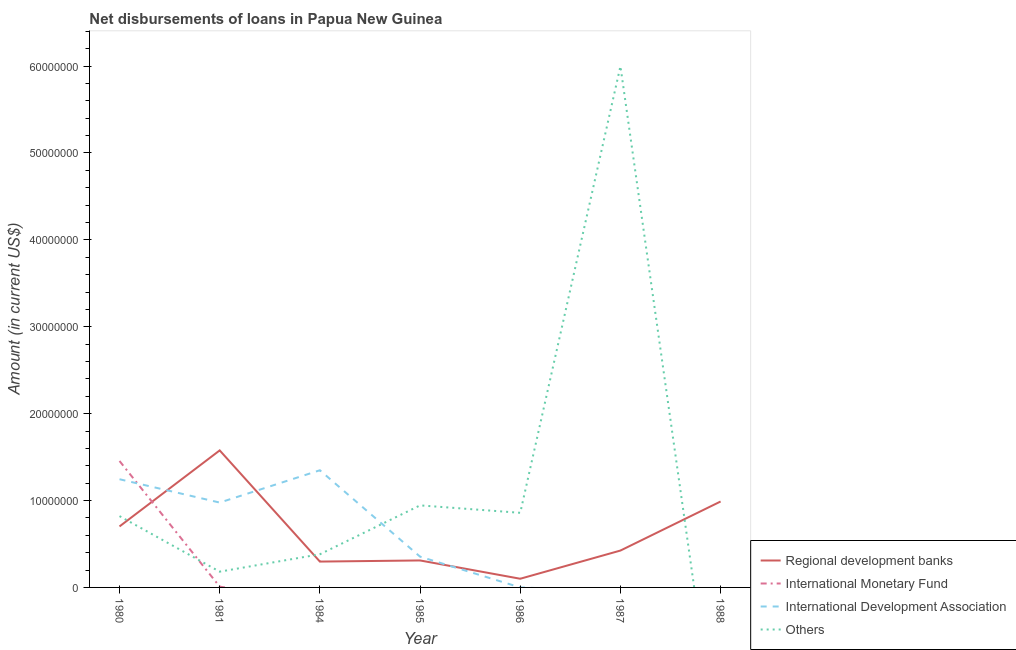Does the line corresponding to amount of loan disimbursed by regional development banks intersect with the line corresponding to amount of loan disimbursed by international development association?
Offer a terse response. Yes. Is the number of lines equal to the number of legend labels?
Offer a terse response. No. What is the amount of loan disimbursed by other organisations in 1980?
Ensure brevity in your answer.  8.21e+06. Across all years, what is the maximum amount of loan disimbursed by international development association?
Provide a succinct answer. 1.35e+07. In which year was the amount of loan disimbursed by international development association maximum?
Your answer should be very brief. 1984. What is the total amount of loan disimbursed by regional development banks in the graph?
Make the answer very short. 4.40e+07. What is the difference between the amount of loan disimbursed by other organisations in 1980 and that in 1986?
Give a very brief answer. -3.80e+05. What is the difference between the amount of loan disimbursed by international development association in 1985 and the amount of loan disimbursed by other organisations in 1980?
Your response must be concise. -4.67e+06. What is the average amount of loan disimbursed by other organisations per year?
Keep it short and to the point. 1.31e+07. In the year 1981, what is the difference between the amount of loan disimbursed by international monetary fund and amount of loan disimbursed by international development association?
Offer a terse response. -9.68e+06. In how many years, is the amount of loan disimbursed by regional development banks greater than 26000000 US$?
Provide a short and direct response. 0. What is the ratio of the amount of loan disimbursed by regional development banks in 1980 to that in 1987?
Ensure brevity in your answer.  1.65. Is the amount of loan disimbursed by regional development banks in 1981 less than that in 1984?
Your answer should be compact. No. What is the difference between the highest and the second highest amount of loan disimbursed by international development association?
Offer a terse response. 1.03e+06. What is the difference between the highest and the lowest amount of loan disimbursed by other organisations?
Offer a very short reply. 6.00e+07. In how many years, is the amount of loan disimbursed by other organisations greater than the average amount of loan disimbursed by other organisations taken over all years?
Offer a terse response. 1. Is it the case that in every year, the sum of the amount of loan disimbursed by regional development banks and amount of loan disimbursed by other organisations is greater than the sum of amount of loan disimbursed by international development association and amount of loan disimbursed by international monetary fund?
Your answer should be compact. No. Is it the case that in every year, the sum of the amount of loan disimbursed by regional development banks and amount of loan disimbursed by international monetary fund is greater than the amount of loan disimbursed by international development association?
Your answer should be compact. No. Does the amount of loan disimbursed by regional development banks monotonically increase over the years?
Provide a short and direct response. No. Is the amount of loan disimbursed by regional development banks strictly greater than the amount of loan disimbursed by international development association over the years?
Your response must be concise. No. How many lines are there?
Offer a terse response. 4. Does the graph contain any zero values?
Ensure brevity in your answer.  Yes. Where does the legend appear in the graph?
Your answer should be very brief. Bottom right. How many legend labels are there?
Give a very brief answer. 4. How are the legend labels stacked?
Your response must be concise. Vertical. What is the title of the graph?
Provide a succinct answer. Net disbursements of loans in Papua New Guinea. Does "Periodicity assessment" appear as one of the legend labels in the graph?
Keep it short and to the point. No. What is the label or title of the X-axis?
Provide a short and direct response. Year. What is the label or title of the Y-axis?
Your response must be concise. Amount (in current US$). What is the Amount (in current US$) of Regional development banks in 1980?
Keep it short and to the point. 7.02e+06. What is the Amount (in current US$) in International Monetary Fund in 1980?
Your answer should be very brief. 1.46e+07. What is the Amount (in current US$) in International Development Association in 1980?
Provide a short and direct response. 1.25e+07. What is the Amount (in current US$) of Others in 1980?
Ensure brevity in your answer.  8.21e+06. What is the Amount (in current US$) in Regional development banks in 1981?
Make the answer very short. 1.58e+07. What is the Amount (in current US$) in International Development Association in 1981?
Your answer should be compact. 9.77e+06. What is the Amount (in current US$) of Others in 1981?
Provide a short and direct response. 1.82e+06. What is the Amount (in current US$) in Regional development banks in 1984?
Your answer should be very brief. 2.98e+06. What is the Amount (in current US$) in International Development Association in 1984?
Make the answer very short. 1.35e+07. What is the Amount (in current US$) of Others in 1984?
Provide a succinct answer. 3.82e+06. What is the Amount (in current US$) of Regional development banks in 1985?
Keep it short and to the point. 3.10e+06. What is the Amount (in current US$) in International Monetary Fund in 1985?
Offer a terse response. 0. What is the Amount (in current US$) of International Development Association in 1985?
Ensure brevity in your answer.  3.54e+06. What is the Amount (in current US$) of Others in 1985?
Ensure brevity in your answer.  9.44e+06. What is the Amount (in current US$) in Regional development banks in 1986?
Your answer should be very brief. 9.99e+05. What is the Amount (in current US$) in International Monetary Fund in 1986?
Make the answer very short. 0. What is the Amount (in current US$) in International Development Association in 1986?
Provide a succinct answer. 0. What is the Amount (in current US$) of Others in 1986?
Your response must be concise. 8.59e+06. What is the Amount (in current US$) in Regional development banks in 1987?
Offer a very short reply. 4.24e+06. What is the Amount (in current US$) in International Development Association in 1987?
Make the answer very short. 0. What is the Amount (in current US$) of Others in 1987?
Offer a terse response. 6.00e+07. What is the Amount (in current US$) of Regional development banks in 1988?
Provide a short and direct response. 9.89e+06. What is the Amount (in current US$) in International Monetary Fund in 1988?
Provide a succinct answer. 0. What is the Amount (in current US$) of Others in 1988?
Your response must be concise. 0. Across all years, what is the maximum Amount (in current US$) of Regional development banks?
Your answer should be very brief. 1.58e+07. Across all years, what is the maximum Amount (in current US$) in International Monetary Fund?
Your answer should be compact. 1.46e+07. Across all years, what is the maximum Amount (in current US$) of International Development Association?
Give a very brief answer. 1.35e+07. Across all years, what is the maximum Amount (in current US$) in Others?
Make the answer very short. 6.00e+07. Across all years, what is the minimum Amount (in current US$) in Regional development banks?
Make the answer very short. 9.99e+05. Across all years, what is the minimum Amount (in current US$) in Others?
Your response must be concise. 0. What is the total Amount (in current US$) in Regional development banks in the graph?
Keep it short and to the point. 4.40e+07. What is the total Amount (in current US$) in International Monetary Fund in the graph?
Your answer should be very brief. 1.46e+07. What is the total Amount (in current US$) of International Development Association in the graph?
Keep it short and to the point. 3.92e+07. What is the total Amount (in current US$) in Others in the graph?
Your answer should be very brief. 9.19e+07. What is the difference between the Amount (in current US$) in Regional development banks in 1980 and that in 1981?
Give a very brief answer. -8.75e+06. What is the difference between the Amount (in current US$) in International Monetary Fund in 1980 and that in 1981?
Make the answer very short. 1.45e+07. What is the difference between the Amount (in current US$) of International Development Association in 1980 and that in 1981?
Provide a succinct answer. 2.69e+06. What is the difference between the Amount (in current US$) in Others in 1980 and that in 1981?
Make the answer very short. 6.39e+06. What is the difference between the Amount (in current US$) in Regional development banks in 1980 and that in 1984?
Your response must be concise. 4.04e+06. What is the difference between the Amount (in current US$) of International Development Association in 1980 and that in 1984?
Offer a very short reply. -1.03e+06. What is the difference between the Amount (in current US$) of Others in 1980 and that in 1984?
Provide a short and direct response. 4.39e+06. What is the difference between the Amount (in current US$) in Regional development banks in 1980 and that in 1985?
Your answer should be very brief. 3.91e+06. What is the difference between the Amount (in current US$) in International Development Association in 1980 and that in 1985?
Provide a succinct answer. 8.91e+06. What is the difference between the Amount (in current US$) in Others in 1980 and that in 1985?
Your answer should be compact. -1.24e+06. What is the difference between the Amount (in current US$) of Regional development banks in 1980 and that in 1986?
Provide a short and direct response. 6.02e+06. What is the difference between the Amount (in current US$) of Others in 1980 and that in 1986?
Keep it short and to the point. -3.80e+05. What is the difference between the Amount (in current US$) in Regional development banks in 1980 and that in 1987?
Offer a terse response. 2.78e+06. What is the difference between the Amount (in current US$) in Others in 1980 and that in 1987?
Make the answer very short. -5.18e+07. What is the difference between the Amount (in current US$) in Regional development banks in 1980 and that in 1988?
Your answer should be compact. -2.87e+06. What is the difference between the Amount (in current US$) of Regional development banks in 1981 and that in 1984?
Make the answer very short. 1.28e+07. What is the difference between the Amount (in current US$) in International Development Association in 1981 and that in 1984?
Keep it short and to the point. -3.72e+06. What is the difference between the Amount (in current US$) of Regional development banks in 1981 and that in 1985?
Your response must be concise. 1.27e+07. What is the difference between the Amount (in current US$) of International Development Association in 1981 and that in 1985?
Keep it short and to the point. 6.23e+06. What is the difference between the Amount (in current US$) of Others in 1981 and that in 1985?
Make the answer very short. -7.63e+06. What is the difference between the Amount (in current US$) of Regional development banks in 1981 and that in 1986?
Provide a succinct answer. 1.48e+07. What is the difference between the Amount (in current US$) of Others in 1981 and that in 1986?
Offer a very short reply. -6.77e+06. What is the difference between the Amount (in current US$) of Regional development banks in 1981 and that in 1987?
Make the answer very short. 1.15e+07. What is the difference between the Amount (in current US$) of Others in 1981 and that in 1987?
Provide a short and direct response. -5.82e+07. What is the difference between the Amount (in current US$) in Regional development banks in 1981 and that in 1988?
Provide a short and direct response. 5.88e+06. What is the difference between the Amount (in current US$) of Regional development banks in 1984 and that in 1985?
Ensure brevity in your answer.  -1.30e+05. What is the difference between the Amount (in current US$) of International Development Association in 1984 and that in 1985?
Offer a terse response. 9.94e+06. What is the difference between the Amount (in current US$) in Others in 1984 and that in 1985?
Provide a short and direct response. -5.63e+06. What is the difference between the Amount (in current US$) of Regional development banks in 1984 and that in 1986?
Offer a very short reply. 1.98e+06. What is the difference between the Amount (in current US$) in Others in 1984 and that in 1986?
Your response must be concise. -4.77e+06. What is the difference between the Amount (in current US$) of Regional development banks in 1984 and that in 1987?
Keep it short and to the point. -1.27e+06. What is the difference between the Amount (in current US$) in Others in 1984 and that in 1987?
Offer a very short reply. -5.62e+07. What is the difference between the Amount (in current US$) of Regional development banks in 1984 and that in 1988?
Your answer should be compact. -6.92e+06. What is the difference between the Amount (in current US$) of Regional development banks in 1985 and that in 1986?
Give a very brief answer. 2.11e+06. What is the difference between the Amount (in current US$) of Others in 1985 and that in 1986?
Your answer should be very brief. 8.56e+05. What is the difference between the Amount (in current US$) of Regional development banks in 1985 and that in 1987?
Your answer should be compact. -1.14e+06. What is the difference between the Amount (in current US$) in Others in 1985 and that in 1987?
Offer a terse response. -5.05e+07. What is the difference between the Amount (in current US$) of Regional development banks in 1985 and that in 1988?
Your response must be concise. -6.79e+06. What is the difference between the Amount (in current US$) in Regional development banks in 1986 and that in 1987?
Give a very brief answer. -3.24e+06. What is the difference between the Amount (in current US$) of Others in 1986 and that in 1987?
Your answer should be very brief. -5.14e+07. What is the difference between the Amount (in current US$) of Regional development banks in 1986 and that in 1988?
Provide a short and direct response. -8.89e+06. What is the difference between the Amount (in current US$) in Regional development banks in 1987 and that in 1988?
Offer a very short reply. -5.65e+06. What is the difference between the Amount (in current US$) in Regional development banks in 1980 and the Amount (in current US$) in International Monetary Fund in 1981?
Your answer should be very brief. 6.93e+06. What is the difference between the Amount (in current US$) of Regional development banks in 1980 and the Amount (in current US$) of International Development Association in 1981?
Make the answer very short. -2.75e+06. What is the difference between the Amount (in current US$) in Regional development banks in 1980 and the Amount (in current US$) in Others in 1981?
Offer a very short reply. 5.20e+06. What is the difference between the Amount (in current US$) in International Monetary Fund in 1980 and the Amount (in current US$) in International Development Association in 1981?
Your answer should be compact. 4.79e+06. What is the difference between the Amount (in current US$) of International Monetary Fund in 1980 and the Amount (in current US$) of Others in 1981?
Offer a terse response. 1.27e+07. What is the difference between the Amount (in current US$) of International Development Association in 1980 and the Amount (in current US$) of Others in 1981?
Your answer should be very brief. 1.06e+07. What is the difference between the Amount (in current US$) of Regional development banks in 1980 and the Amount (in current US$) of International Development Association in 1984?
Make the answer very short. -6.46e+06. What is the difference between the Amount (in current US$) of Regional development banks in 1980 and the Amount (in current US$) of Others in 1984?
Provide a short and direct response. 3.20e+06. What is the difference between the Amount (in current US$) of International Monetary Fund in 1980 and the Amount (in current US$) of International Development Association in 1984?
Your answer should be compact. 1.07e+06. What is the difference between the Amount (in current US$) in International Monetary Fund in 1980 and the Amount (in current US$) in Others in 1984?
Make the answer very short. 1.07e+07. What is the difference between the Amount (in current US$) in International Development Association in 1980 and the Amount (in current US$) in Others in 1984?
Your response must be concise. 8.64e+06. What is the difference between the Amount (in current US$) of Regional development banks in 1980 and the Amount (in current US$) of International Development Association in 1985?
Give a very brief answer. 3.48e+06. What is the difference between the Amount (in current US$) of Regional development banks in 1980 and the Amount (in current US$) of Others in 1985?
Give a very brief answer. -2.42e+06. What is the difference between the Amount (in current US$) of International Monetary Fund in 1980 and the Amount (in current US$) of International Development Association in 1985?
Provide a short and direct response. 1.10e+07. What is the difference between the Amount (in current US$) of International Monetary Fund in 1980 and the Amount (in current US$) of Others in 1985?
Keep it short and to the point. 5.11e+06. What is the difference between the Amount (in current US$) in International Development Association in 1980 and the Amount (in current US$) in Others in 1985?
Offer a very short reply. 3.01e+06. What is the difference between the Amount (in current US$) in Regional development banks in 1980 and the Amount (in current US$) in Others in 1986?
Your answer should be compact. -1.57e+06. What is the difference between the Amount (in current US$) of International Monetary Fund in 1980 and the Amount (in current US$) of Others in 1986?
Your answer should be very brief. 5.96e+06. What is the difference between the Amount (in current US$) of International Development Association in 1980 and the Amount (in current US$) of Others in 1986?
Provide a succinct answer. 3.86e+06. What is the difference between the Amount (in current US$) in Regional development banks in 1980 and the Amount (in current US$) in Others in 1987?
Make the answer very short. -5.30e+07. What is the difference between the Amount (in current US$) of International Monetary Fund in 1980 and the Amount (in current US$) of Others in 1987?
Give a very brief answer. -4.54e+07. What is the difference between the Amount (in current US$) of International Development Association in 1980 and the Amount (in current US$) of Others in 1987?
Offer a very short reply. -4.75e+07. What is the difference between the Amount (in current US$) of Regional development banks in 1981 and the Amount (in current US$) of International Development Association in 1984?
Your response must be concise. 2.29e+06. What is the difference between the Amount (in current US$) of Regional development banks in 1981 and the Amount (in current US$) of Others in 1984?
Keep it short and to the point. 1.20e+07. What is the difference between the Amount (in current US$) in International Monetary Fund in 1981 and the Amount (in current US$) in International Development Association in 1984?
Your answer should be very brief. -1.34e+07. What is the difference between the Amount (in current US$) of International Monetary Fund in 1981 and the Amount (in current US$) of Others in 1984?
Your response must be concise. -3.72e+06. What is the difference between the Amount (in current US$) in International Development Association in 1981 and the Amount (in current US$) in Others in 1984?
Your response must be concise. 5.95e+06. What is the difference between the Amount (in current US$) of Regional development banks in 1981 and the Amount (in current US$) of International Development Association in 1985?
Provide a short and direct response. 1.22e+07. What is the difference between the Amount (in current US$) of Regional development banks in 1981 and the Amount (in current US$) of Others in 1985?
Your answer should be very brief. 6.33e+06. What is the difference between the Amount (in current US$) in International Monetary Fund in 1981 and the Amount (in current US$) in International Development Association in 1985?
Offer a very short reply. -3.45e+06. What is the difference between the Amount (in current US$) of International Monetary Fund in 1981 and the Amount (in current US$) of Others in 1985?
Your response must be concise. -9.35e+06. What is the difference between the Amount (in current US$) in International Development Association in 1981 and the Amount (in current US$) in Others in 1985?
Offer a very short reply. 3.23e+05. What is the difference between the Amount (in current US$) of Regional development banks in 1981 and the Amount (in current US$) of Others in 1986?
Ensure brevity in your answer.  7.18e+06. What is the difference between the Amount (in current US$) in International Monetary Fund in 1981 and the Amount (in current US$) in Others in 1986?
Make the answer very short. -8.50e+06. What is the difference between the Amount (in current US$) in International Development Association in 1981 and the Amount (in current US$) in Others in 1986?
Give a very brief answer. 1.18e+06. What is the difference between the Amount (in current US$) in Regional development banks in 1981 and the Amount (in current US$) in Others in 1987?
Provide a succinct answer. -4.42e+07. What is the difference between the Amount (in current US$) in International Monetary Fund in 1981 and the Amount (in current US$) in Others in 1987?
Your answer should be compact. -5.99e+07. What is the difference between the Amount (in current US$) in International Development Association in 1981 and the Amount (in current US$) in Others in 1987?
Your response must be concise. -5.02e+07. What is the difference between the Amount (in current US$) in Regional development banks in 1984 and the Amount (in current US$) in International Development Association in 1985?
Ensure brevity in your answer.  -5.65e+05. What is the difference between the Amount (in current US$) of Regional development banks in 1984 and the Amount (in current US$) of Others in 1985?
Provide a succinct answer. -6.47e+06. What is the difference between the Amount (in current US$) of International Development Association in 1984 and the Amount (in current US$) of Others in 1985?
Ensure brevity in your answer.  4.04e+06. What is the difference between the Amount (in current US$) in Regional development banks in 1984 and the Amount (in current US$) in Others in 1986?
Provide a succinct answer. -5.61e+06. What is the difference between the Amount (in current US$) of International Development Association in 1984 and the Amount (in current US$) of Others in 1986?
Give a very brief answer. 4.90e+06. What is the difference between the Amount (in current US$) of Regional development banks in 1984 and the Amount (in current US$) of Others in 1987?
Make the answer very short. -5.70e+07. What is the difference between the Amount (in current US$) in International Development Association in 1984 and the Amount (in current US$) in Others in 1987?
Keep it short and to the point. -4.65e+07. What is the difference between the Amount (in current US$) of Regional development banks in 1985 and the Amount (in current US$) of Others in 1986?
Your answer should be very brief. -5.48e+06. What is the difference between the Amount (in current US$) of International Development Association in 1985 and the Amount (in current US$) of Others in 1986?
Your response must be concise. -5.05e+06. What is the difference between the Amount (in current US$) in Regional development banks in 1985 and the Amount (in current US$) in Others in 1987?
Provide a succinct answer. -5.69e+07. What is the difference between the Amount (in current US$) in International Development Association in 1985 and the Amount (in current US$) in Others in 1987?
Keep it short and to the point. -5.64e+07. What is the difference between the Amount (in current US$) in Regional development banks in 1986 and the Amount (in current US$) in Others in 1987?
Ensure brevity in your answer.  -5.90e+07. What is the average Amount (in current US$) in Regional development banks per year?
Provide a succinct answer. 6.29e+06. What is the average Amount (in current US$) of International Monetary Fund per year?
Ensure brevity in your answer.  2.09e+06. What is the average Amount (in current US$) of International Development Association per year?
Provide a short and direct response. 5.61e+06. What is the average Amount (in current US$) in Others per year?
Offer a terse response. 1.31e+07. In the year 1980, what is the difference between the Amount (in current US$) in Regional development banks and Amount (in current US$) in International Monetary Fund?
Offer a terse response. -7.53e+06. In the year 1980, what is the difference between the Amount (in current US$) of Regional development banks and Amount (in current US$) of International Development Association?
Provide a short and direct response. -5.43e+06. In the year 1980, what is the difference between the Amount (in current US$) of Regional development banks and Amount (in current US$) of Others?
Offer a very short reply. -1.19e+06. In the year 1980, what is the difference between the Amount (in current US$) in International Monetary Fund and Amount (in current US$) in International Development Association?
Provide a succinct answer. 2.10e+06. In the year 1980, what is the difference between the Amount (in current US$) in International Monetary Fund and Amount (in current US$) in Others?
Provide a short and direct response. 6.34e+06. In the year 1980, what is the difference between the Amount (in current US$) of International Development Association and Amount (in current US$) of Others?
Your answer should be compact. 4.24e+06. In the year 1981, what is the difference between the Amount (in current US$) in Regional development banks and Amount (in current US$) in International Monetary Fund?
Keep it short and to the point. 1.57e+07. In the year 1981, what is the difference between the Amount (in current US$) of Regional development banks and Amount (in current US$) of International Development Association?
Your answer should be very brief. 6.00e+06. In the year 1981, what is the difference between the Amount (in current US$) of Regional development banks and Amount (in current US$) of Others?
Offer a terse response. 1.40e+07. In the year 1981, what is the difference between the Amount (in current US$) in International Monetary Fund and Amount (in current US$) in International Development Association?
Provide a succinct answer. -9.68e+06. In the year 1981, what is the difference between the Amount (in current US$) of International Monetary Fund and Amount (in current US$) of Others?
Give a very brief answer. -1.72e+06. In the year 1981, what is the difference between the Amount (in current US$) in International Development Association and Amount (in current US$) in Others?
Ensure brevity in your answer.  7.95e+06. In the year 1984, what is the difference between the Amount (in current US$) in Regional development banks and Amount (in current US$) in International Development Association?
Your answer should be compact. -1.05e+07. In the year 1984, what is the difference between the Amount (in current US$) in Regional development banks and Amount (in current US$) in Others?
Provide a short and direct response. -8.40e+05. In the year 1984, what is the difference between the Amount (in current US$) in International Development Association and Amount (in current US$) in Others?
Provide a short and direct response. 9.67e+06. In the year 1985, what is the difference between the Amount (in current US$) in Regional development banks and Amount (in current US$) in International Development Association?
Keep it short and to the point. -4.35e+05. In the year 1985, what is the difference between the Amount (in current US$) in Regional development banks and Amount (in current US$) in Others?
Offer a terse response. -6.34e+06. In the year 1985, what is the difference between the Amount (in current US$) in International Development Association and Amount (in current US$) in Others?
Provide a succinct answer. -5.90e+06. In the year 1986, what is the difference between the Amount (in current US$) of Regional development banks and Amount (in current US$) of Others?
Keep it short and to the point. -7.59e+06. In the year 1987, what is the difference between the Amount (in current US$) in Regional development banks and Amount (in current US$) in Others?
Provide a short and direct response. -5.57e+07. What is the ratio of the Amount (in current US$) in Regional development banks in 1980 to that in 1981?
Offer a terse response. 0.45. What is the ratio of the Amount (in current US$) of International Monetary Fund in 1980 to that in 1981?
Give a very brief answer. 161.69. What is the ratio of the Amount (in current US$) in International Development Association in 1980 to that in 1981?
Give a very brief answer. 1.27. What is the ratio of the Amount (in current US$) in Others in 1980 to that in 1981?
Your answer should be compact. 4.52. What is the ratio of the Amount (in current US$) in Regional development banks in 1980 to that in 1984?
Provide a short and direct response. 2.36. What is the ratio of the Amount (in current US$) of International Development Association in 1980 to that in 1984?
Offer a terse response. 0.92. What is the ratio of the Amount (in current US$) in Others in 1980 to that in 1984?
Your answer should be very brief. 2.15. What is the ratio of the Amount (in current US$) in Regional development banks in 1980 to that in 1985?
Keep it short and to the point. 2.26. What is the ratio of the Amount (in current US$) in International Development Association in 1980 to that in 1985?
Provide a short and direct response. 3.52. What is the ratio of the Amount (in current US$) in Others in 1980 to that in 1985?
Give a very brief answer. 0.87. What is the ratio of the Amount (in current US$) of Regional development banks in 1980 to that in 1986?
Provide a short and direct response. 7.03. What is the ratio of the Amount (in current US$) in Others in 1980 to that in 1986?
Keep it short and to the point. 0.96. What is the ratio of the Amount (in current US$) in Regional development banks in 1980 to that in 1987?
Provide a succinct answer. 1.65. What is the ratio of the Amount (in current US$) of Others in 1980 to that in 1987?
Make the answer very short. 0.14. What is the ratio of the Amount (in current US$) in Regional development banks in 1980 to that in 1988?
Provide a short and direct response. 0.71. What is the ratio of the Amount (in current US$) of Regional development banks in 1981 to that in 1984?
Keep it short and to the point. 5.3. What is the ratio of the Amount (in current US$) in International Development Association in 1981 to that in 1984?
Your answer should be very brief. 0.72. What is the ratio of the Amount (in current US$) of Others in 1981 to that in 1984?
Offer a terse response. 0.48. What is the ratio of the Amount (in current US$) in Regional development banks in 1981 to that in 1985?
Provide a succinct answer. 5.08. What is the ratio of the Amount (in current US$) in International Development Association in 1981 to that in 1985?
Make the answer very short. 2.76. What is the ratio of the Amount (in current US$) in Others in 1981 to that in 1985?
Offer a terse response. 0.19. What is the ratio of the Amount (in current US$) of Regional development banks in 1981 to that in 1986?
Offer a very short reply. 15.79. What is the ratio of the Amount (in current US$) of Others in 1981 to that in 1986?
Your answer should be compact. 0.21. What is the ratio of the Amount (in current US$) in Regional development banks in 1981 to that in 1987?
Your answer should be compact. 3.72. What is the ratio of the Amount (in current US$) of Others in 1981 to that in 1987?
Make the answer very short. 0.03. What is the ratio of the Amount (in current US$) in Regional development banks in 1981 to that in 1988?
Your response must be concise. 1.59. What is the ratio of the Amount (in current US$) of Regional development banks in 1984 to that in 1985?
Your response must be concise. 0.96. What is the ratio of the Amount (in current US$) in International Development Association in 1984 to that in 1985?
Keep it short and to the point. 3.81. What is the ratio of the Amount (in current US$) in Others in 1984 to that in 1985?
Your response must be concise. 0.4. What is the ratio of the Amount (in current US$) of Regional development banks in 1984 to that in 1986?
Your answer should be compact. 2.98. What is the ratio of the Amount (in current US$) in Others in 1984 to that in 1986?
Keep it short and to the point. 0.44. What is the ratio of the Amount (in current US$) of Regional development banks in 1984 to that in 1987?
Your answer should be compact. 0.7. What is the ratio of the Amount (in current US$) in Others in 1984 to that in 1987?
Keep it short and to the point. 0.06. What is the ratio of the Amount (in current US$) of Regional development banks in 1984 to that in 1988?
Your answer should be compact. 0.3. What is the ratio of the Amount (in current US$) of Regional development banks in 1985 to that in 1986?
Your answer should be very brief. 3.11. What is the ratio of the Amount (in current US$) in Others in 1985 to that in 1986?
Your answer should be very brief. 1.1. What is the ratio of the Amount (in current US$) of Regional development banks in 1985 to that in 1987?
Your response must be concise. 0.73. What is the ratio of the Amount (in current US$) of Others in 1985 to that in 1987?
Offer a terse response. 0.16. What is the ratio of the Amount (in current US$) of Regional development banks in 1985 to that in 1988?
Your answer should be very brief. 0.31. What is the ratio of the Amount (in current US$) of Regional development banks in 1986 to that in 1987?
Your response must be concise. 0.24. What is the ratio of the Amount (in current US$) of Others in 1986 to that in 1987?
Offer a terse response. 0.14. What is the ratio of the Amount (in current US$) of Regional development banks in 1986 to that in 1988?
Your answer should be compact. 0.1. What is the ratio of the Amount (in current US$) of Regional development banks in 1987 to that in 1988?
Your response must be concise. 0.43. What is the difference between the highest and the second highest Amount (in current US$) of Regional development banks?
Offer a terse response. 5.88e+06. What is the difference between the highest and the second highest Amount (in current US$) of International Development Association?
Make the answer very short. 1.03e+06. What is the difference between the highest and the second highest Amount (in current US$) in Others?
Offer a terse response. 5.05e+07. What is the difference between the highest and the lowest Amount (in current US$) of Regional development banks?
Offer a very short reply. 1.48e+07. What is the difference between the highest and the lowest Amount (in current US$) of International Monetary Fund?
Offer a very short reply. 1.46e+07. What is the difference between the highest and the lowest Amount (in current US$) of International Development Association?
Provide a succinct answer. 1.35e+07. What is the difference between the highest and the lowest Amount (in current US$) of Others?
Your answer should be compact. 6.00e+07. 